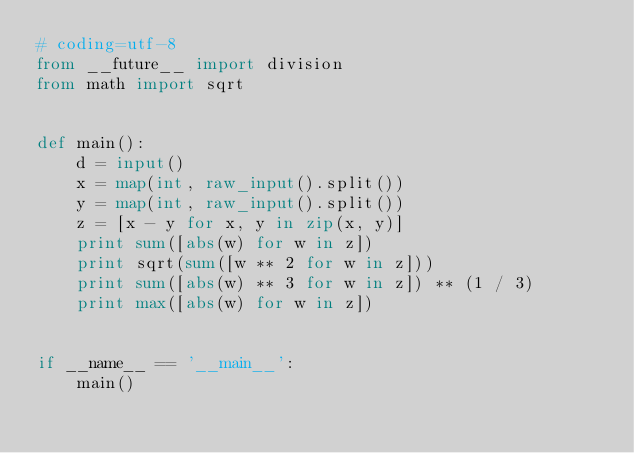<code> <loc_0><loc_0><loc_500><loc_500><_Python_># coding=utf-8
from __future__ import division
from math import sqrt


def main():
    d = input()
    x = map(int, raw_input().split())
    y = map(int, raw_input().split())
    z = [x - y for x, y in zip(x, y)]
    print sum([abs(w) for w in z])
    print sqrt(sum([w ** 2 for w in z]))
    print sum([abs(w) ** 3 for w in z]) ** (1 / 3)
    print max([abs(w) for w in z])


if __name__ == '__main__':
    main()</code> 